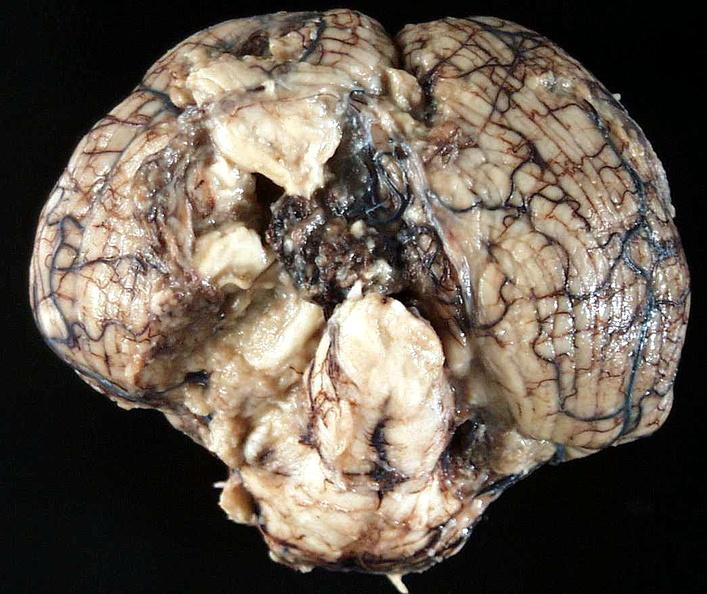what does this image show?
Answer the question using a single word or phrase. Brain 